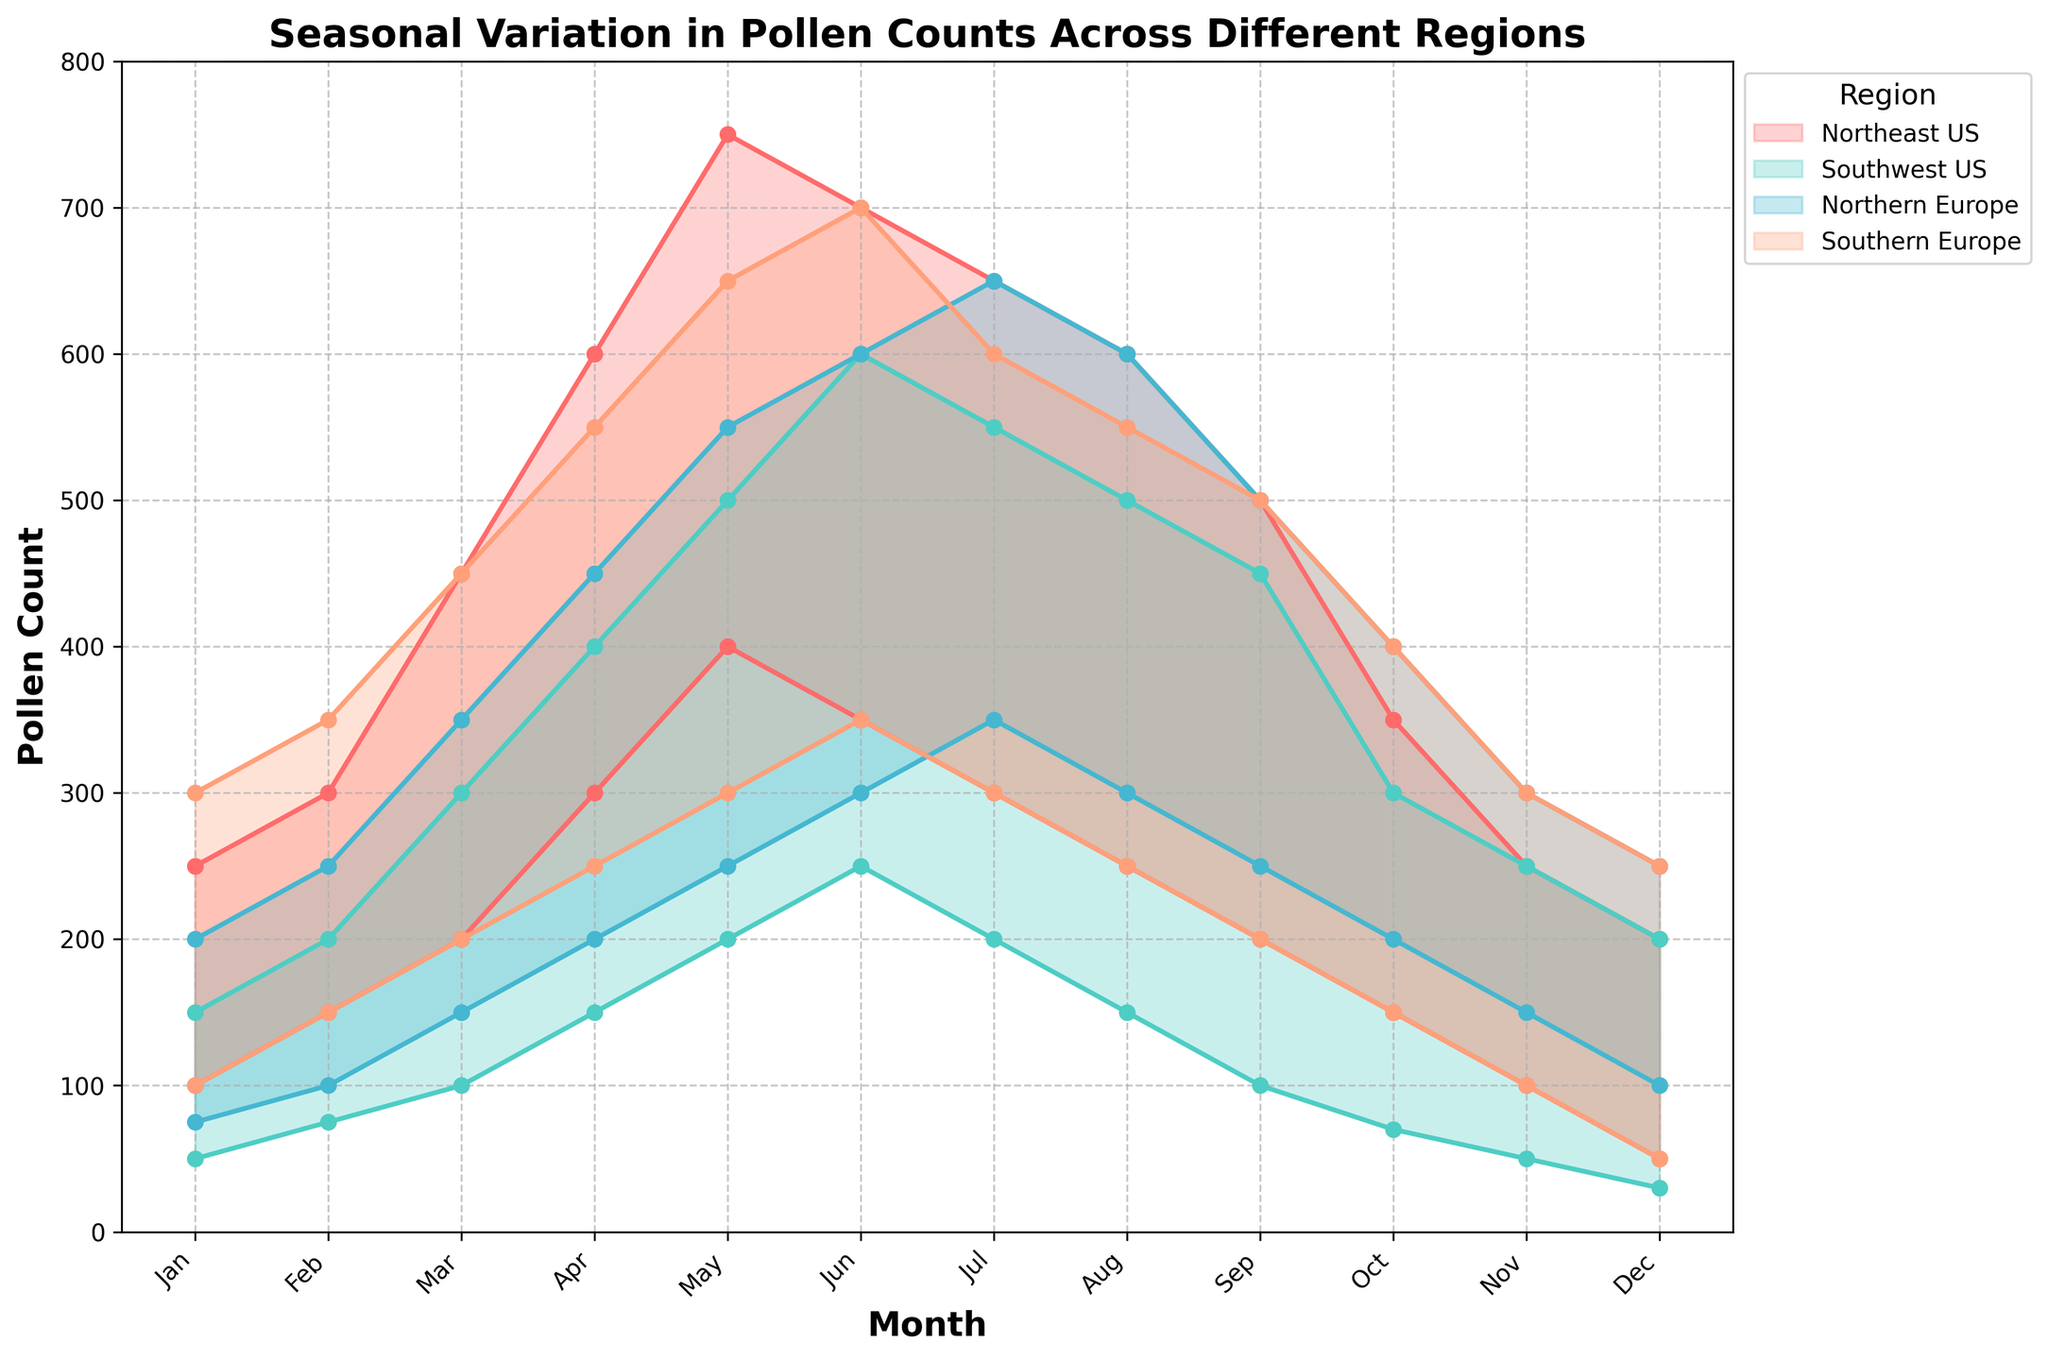What is the title of the figure? The title of the figure is found at the top and often summarizes the main topic of the chart. Here, it reads "Seasonal Variation in Pollen Counts Across Different Regions."
Answer: Seasonal Variation in Pollen Counts Across Different Regions Which region has the highest peak in pollen count, and in which month does it occur? By visually inspecting the peaks of the shaded areas for each region, Southern Europe reaches the highest maximum pollen count of 700, which occurs in June.
Answer: Southern Europe, June What are the months with the lowest minimum pollen counts for Northeast US and Southwest US? By looking at the lowest ends of the filled areas for both regions, the lowest minimum pollen counts for Northeast US is 50 in December and for Southwest US is 30 in December.
Answer: Northeast US: December, Southwest US: December How do the pollen counts in Northern Europe compare between January and July? In January, the range is from 75 to 200. In July, the range is from 350 to 650. This indicates a significant increase in both the minimum and maximum pollen counts from January to July.
Answer: They increase significantly What is the range of pollen counts for Southern Europe in May? To find the range, we look at the shaded areas for Southern Europe in May, which shows a minimum of 300 and a maximum of 650. Thus, the range is 650 - 300 = 350.
Answer: 350 During which months do all regions have at least 100 pollen counts at their minimum? By examining the lowest points in each region’s shaded area, all regions have at least 100 pollen counts at their minimum from March to November.
Answer: March to November For the Northeast US, which month shows the greatest difference between maximum and minimum pollen counts? By calculating the difference between the maximum and minimum pollen counts for each month, April shows the greatest difference (600 - 300 = 300).
Answer: April Which region shows the least seasonal variation in pollen counts? Least variation can be interpreted by looking at the consistency in the shaded areas. Southwest US shows the smallest difference between min and max pollen counts throughout the year.
Answer: Southwest US Compare the pollen count trends between Northern Europe and Southern Europe. What do you observe? By comparing the shaded areas across months, we see that Northern Europe has a gradual and consistent increase followed by a decrease, whereas Southern Europe also peaks but with slightly higher pollen counts and a sharper decline. Both regions, however, have similar patterns overall.
Answer: Both have similar patterns, with Southern Europe having slightly higher counts and sharper declines In which month does Northern Europe reach its peak maximum pollen count, and what is the count? By observing the highest point of the shaded area for Northern Europe, the peak is in July with a maximum pollen count of 650.
Answer: July, 650 